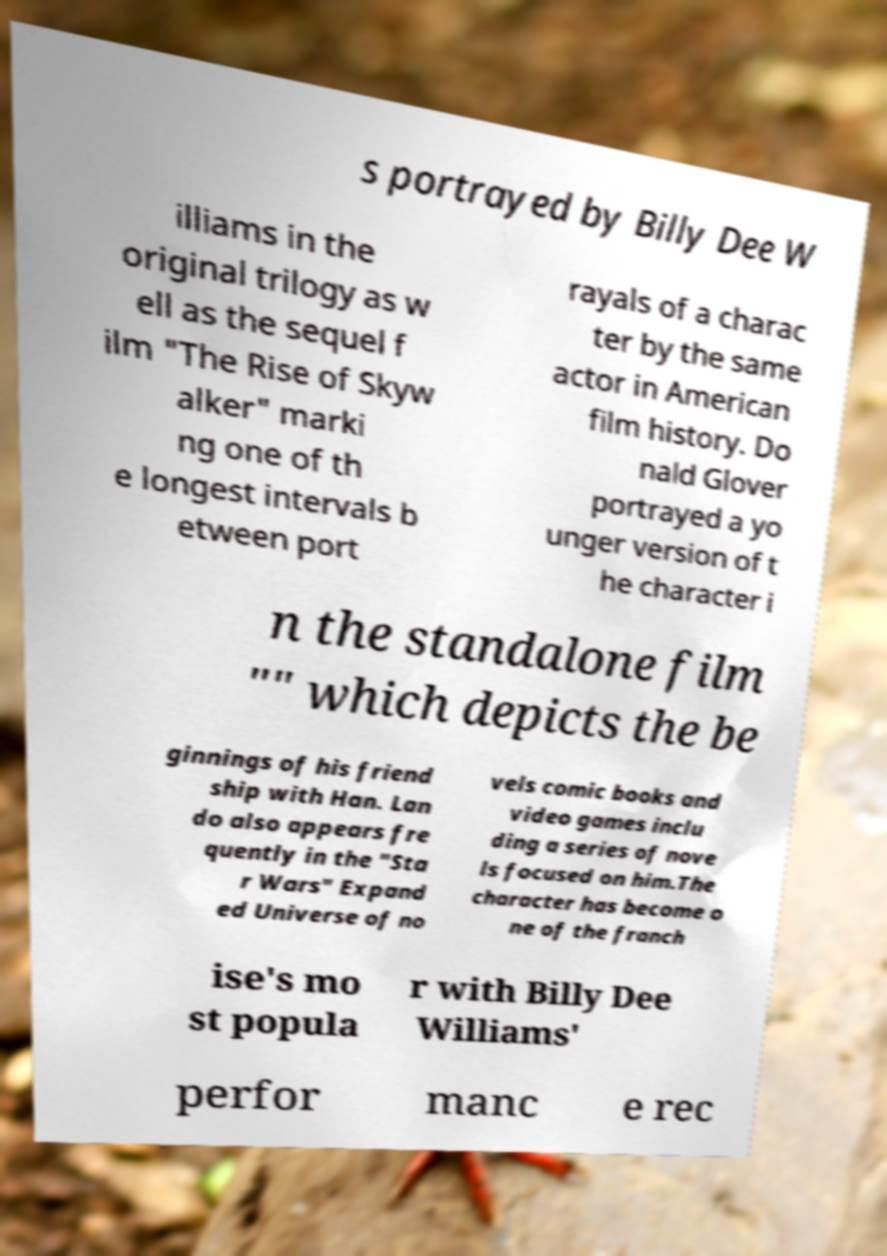Please identify and transcribe the text found in this image. s portrayed by Billy Dee W illiams in the original trilogy as w ell as the sequel f ilm "The Rise of Skyw alker" marki ng one of th e longest intervals b etween port rayals of a charac ter by the same actor in American film history. Do nald Glover portrayed a yo unger version of t he character i n the standalone film "" which depicts the be ginnings of his friend ship with Han. Lan do also appears fre quently in the "Sta r Wars" Expand ed Universe of no vels comic books and video games inclu ding a series of nove ls focused on him.The character has become o ne of the franch ise's mo st popula r with Billy Dee Williams' perfor manc e rec 